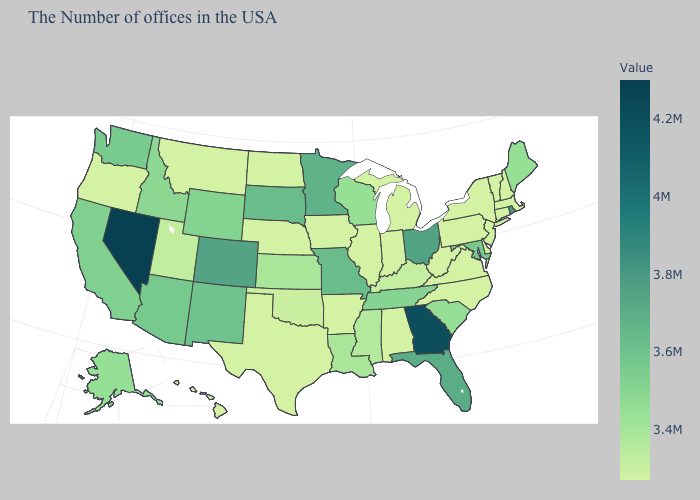Does the map have missing data?
Answer briefly. No. Does Nevada have the highest value in the USA?
Keep it brief. Yes. Does Washington have the lowest value in the West?
Concise answer only. No. Does Utah have the lowest value in the West?
Keep it brief. No. Which states hav the highest value in the MidWest?
Be succinct. Ohio. 